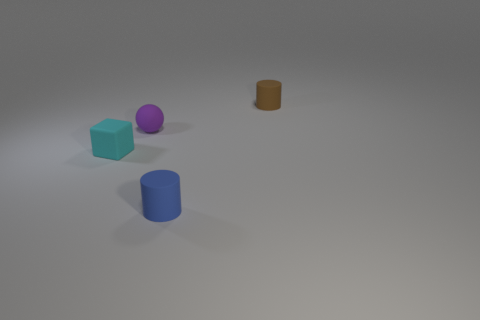What number of blue cylinders are the same material as the block? From the image, it appears that there is one blue cylinder that has a surface texture and reflectivity akin to the blue block, implying they are the same material. 